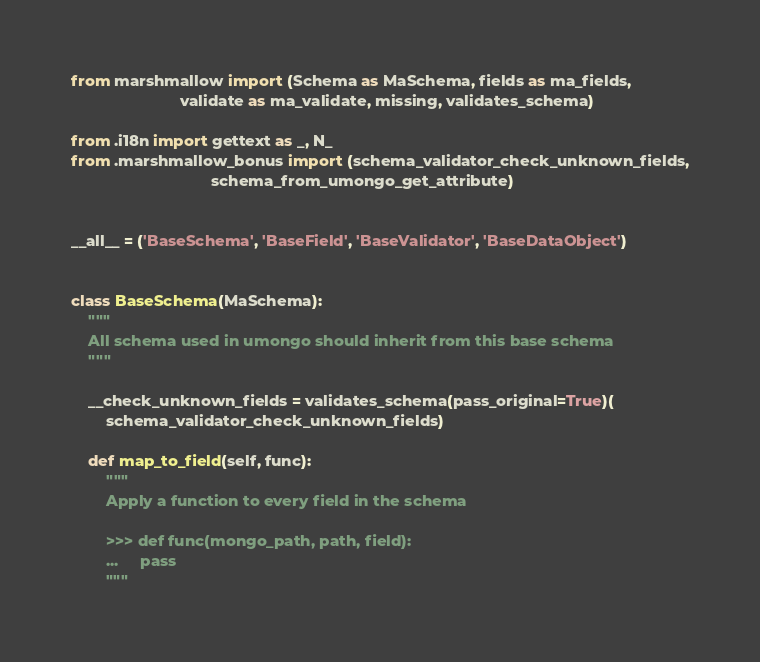Convert code to text. <code><loc_0><loc_0><loc_500><loc_500><_Python_>from marshmallow import (Schema as MaSchema, fields as ma_fields,
                         validate as ma_validate, missing, validates_schema)

from .i18n import gettext as _, N_
from .marshmallow_bonus import (schema_validator_check_unknown_fields,
                                schema_from_umongo_get_attribute)


__all__ = ('BaseSchema', 'BaseField', 'BaseValidator', 'BaseDataObject')


class BaseSchema(MaSchema):
    """
    All schema used in umongo should inherit from this base schema
    """

    __check_unknown_fields = validates_schema(pass_original=True)(
        schema_validator_check_unknown_fields)

    def map_to_field(self, func):
        """
        Apply a function to every field in the schema

        >>> def func(mongo_path, path, field):
        ...     pass
        """</code> 